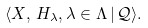Convert formula to latex. <formula><loc_0><loc_0><loc_500><loc_500>\langle X , \, H _ { \lambda } , \lambda \in \Lambda \, | \, \mathcal { Q } \rangle .</formula> 